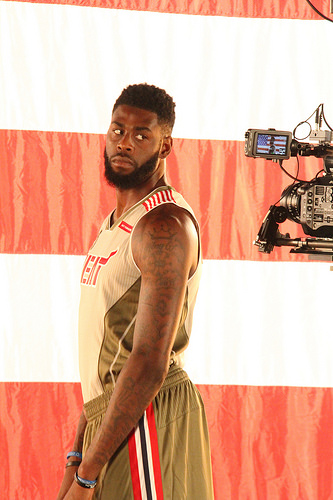<image>
Is the tattoo in front of the american flag? Yes. The tattoo is positioned in front of the american flag, appearing closer to the camera viewpoint. 